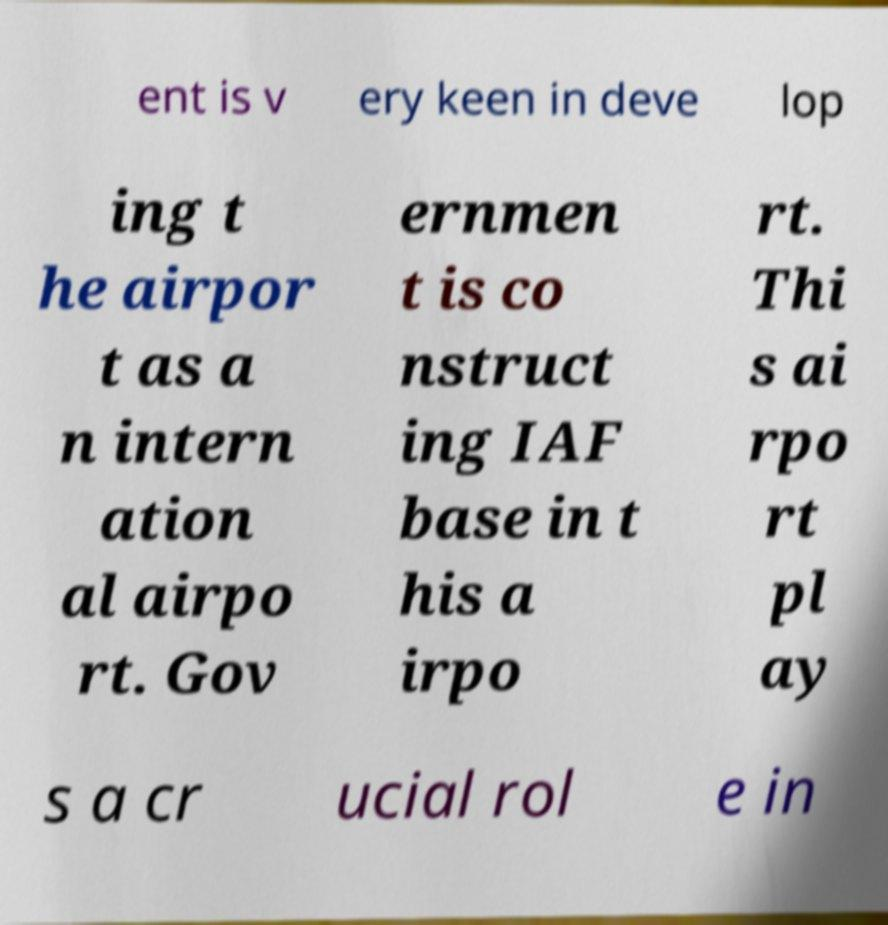I need the written content from this picture converted into text. Can you do that? ent is v ery keen in deve lop ing t he airpor t as a n intern ation al airpo rt. Gov ernmen t is co nstruct ing IAF base in t his a irpo rt. Thi s ai rpo rt pl ay s a cr ucial rol e in 